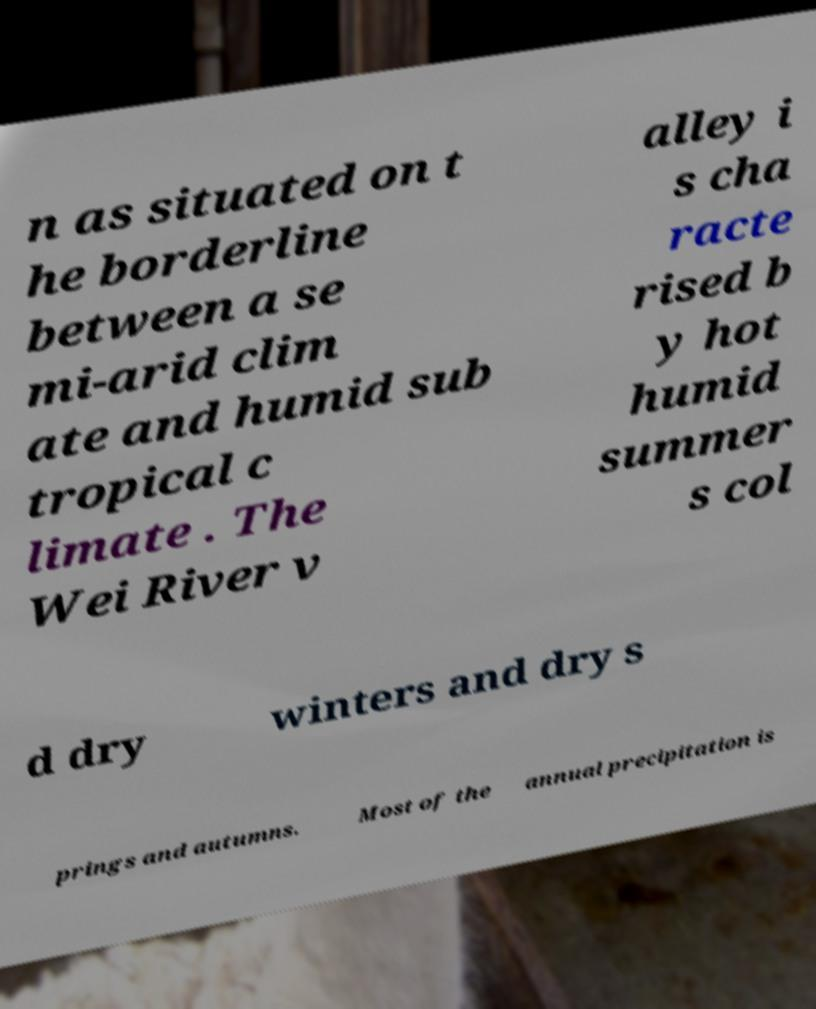Could you assist in decoding the text presented in this image and type it out clearly? n as situated on t he borderline between a se mi-arid clim ate and humid sub tropical c limate . The Wei River v alley i s cha racte rised b y hot humid summer s col d dry winters and dry s prings and autumns. Most of the annual precipitation is 